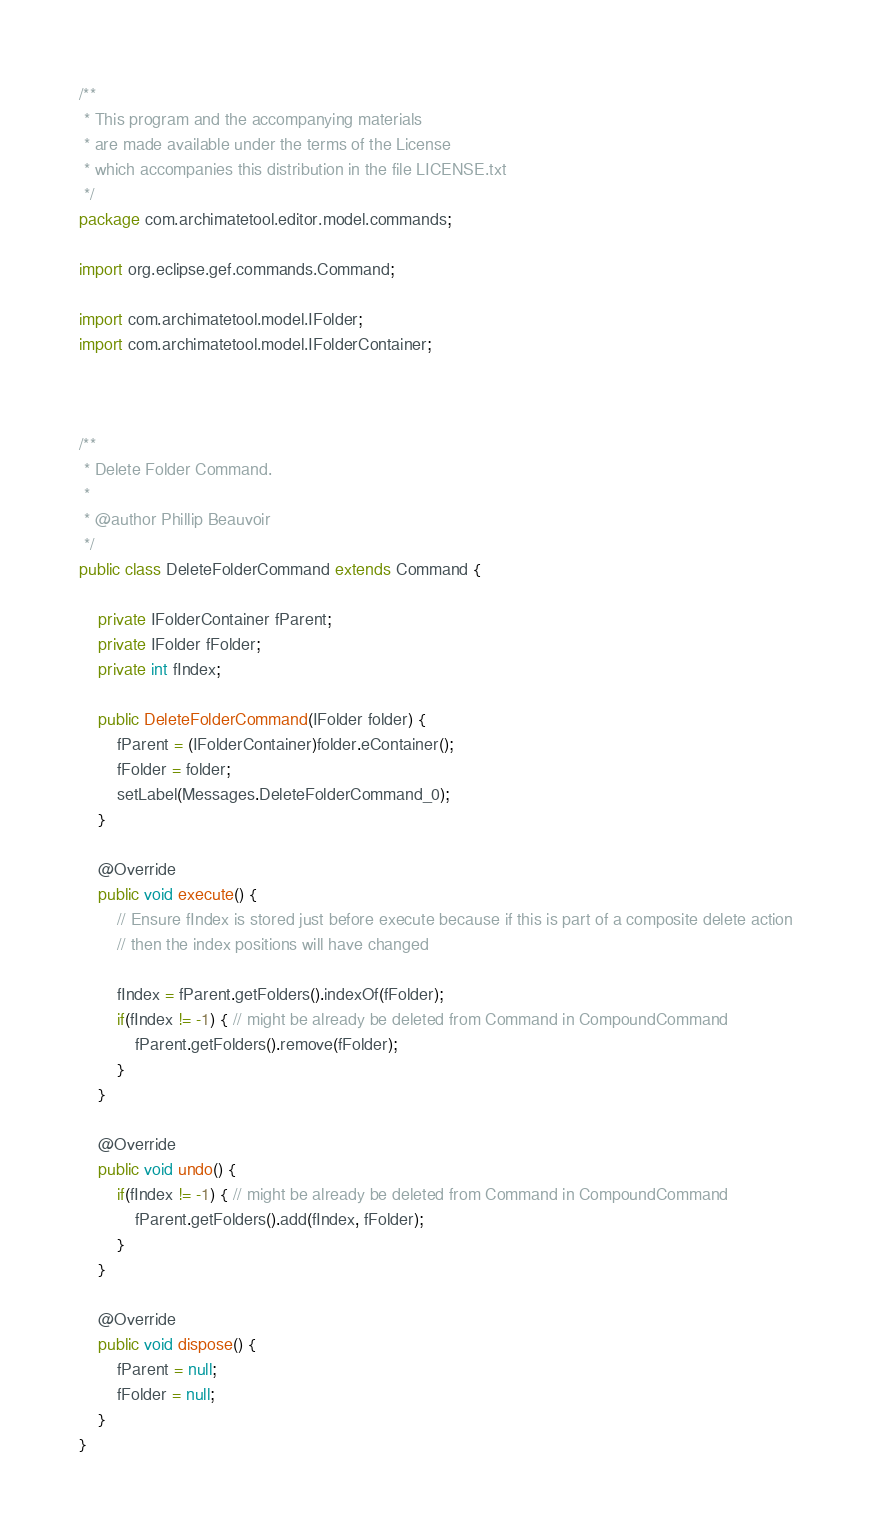Convert code to text. <code><loc_0><loc_0><loc_500><loc_500><_Java_>/**
 * This program and the accompanying materials
 * are made available under the terms of the License
 * which accompanies this distribution in the file LICENSE.txt
 */
package com.archimatetool.editor.model.commands;

import org.eclipse.gef.commands.Command;

import com.archimatetool.model.IFolder;
import com.archimatetool.model.IFolderContainer;



/**
 * Delete Folder Command.
 * 
 * @author Phillip Beauvoir
 */
public class DeleteFolderCommand extends Command {
    
    private IFolderContainer fParent;
    private IFolder fFolder;
    private int fIndex;

    public DeleteFolderCommand(IFolder folder) {
        fParent = (IFolderContainer)folder.eContainer();
        fFolder = folder;
        setLabel(Messages.DeleteFolderCommand_0);
    }
    
    @Override
    public void execute() {
        // Ensure fIndex is stored just before execute because if this is part of a composite delete action
        // then the index positions will have changed
        
        fIndex = fParent.getFolders().indexOf(fFolder); 
        if(fIndex != -1) { // might be already be deleted from Command in CompoundCommand
            fParent.getFolders().remove(fFolder);
        }
    }
    
    @Override
    public void undo() {
        if(fIndex != -1) { // might be already be deleted from Command in CompoundCommand
            fParent.getFolders().add(fIndex, fFolder);
        }
    }
    
    @Override
    public void dispose() {
        fParent = null;
        fFolder = null;
    }
}
</code> 